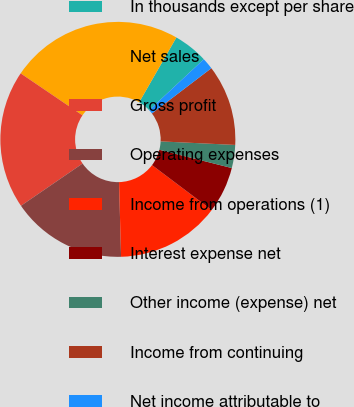<chart> <loc_0><loc_0><loc_500><loc_500><pie_chart><fcel>In thousands except per share<fcel>Net sales<fcel>Gross profit<fcel>Operating expenses<fcel>Income from operations (1)<fcel>Interest expense net<fcel>Other income (expense) net<fcel>Income from continuing<fcel>Net income attributable to<nl><fcel>4.76%<fcel>23.81%<fcel>19.05%<fcel>15.87%<fcel>14.29%<fcel>6.35%<fcel>3.17%<fcel>11.11%<fcel>1.59%<nl></chart> 